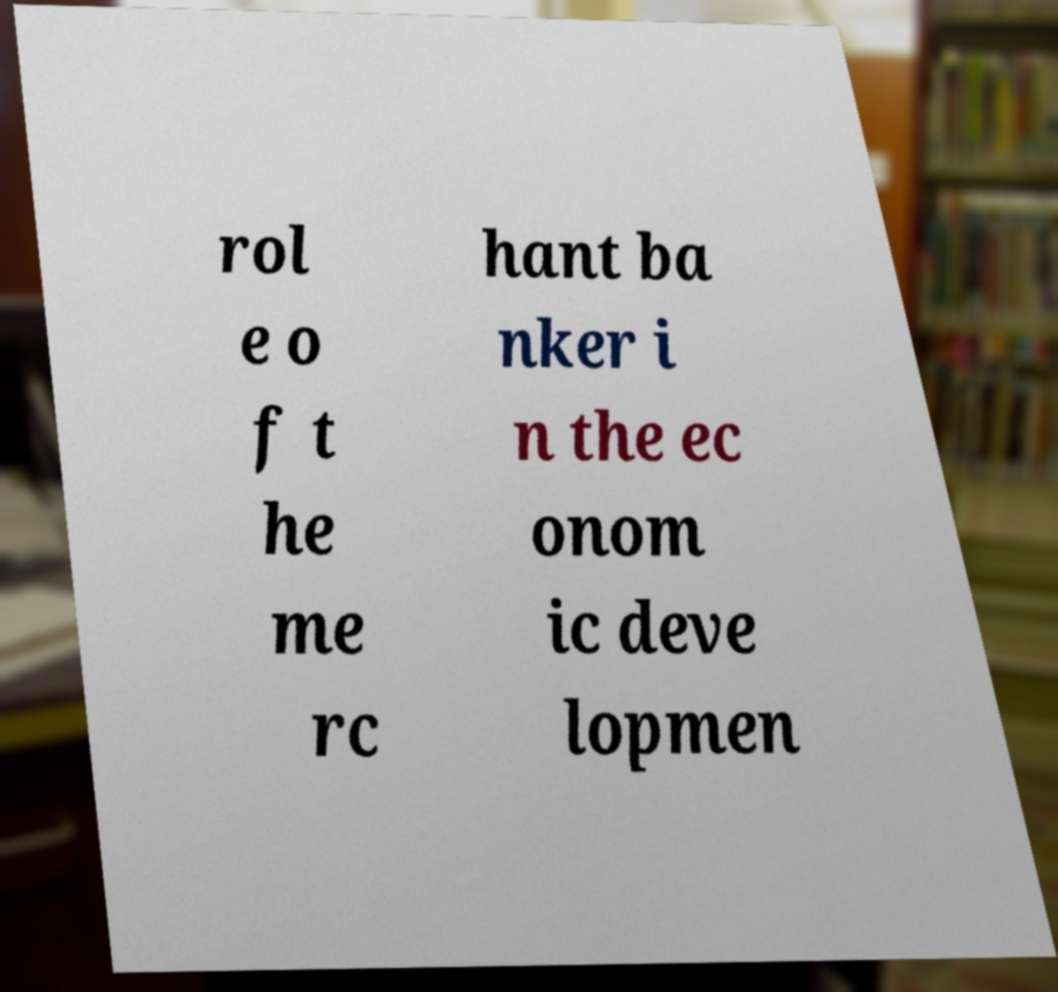There's text embedded in this image that I need extracted. Can you transcribe it verbatim? rol e o f t he me rc hant ba nker i n the ec onom ic deve lopmen 